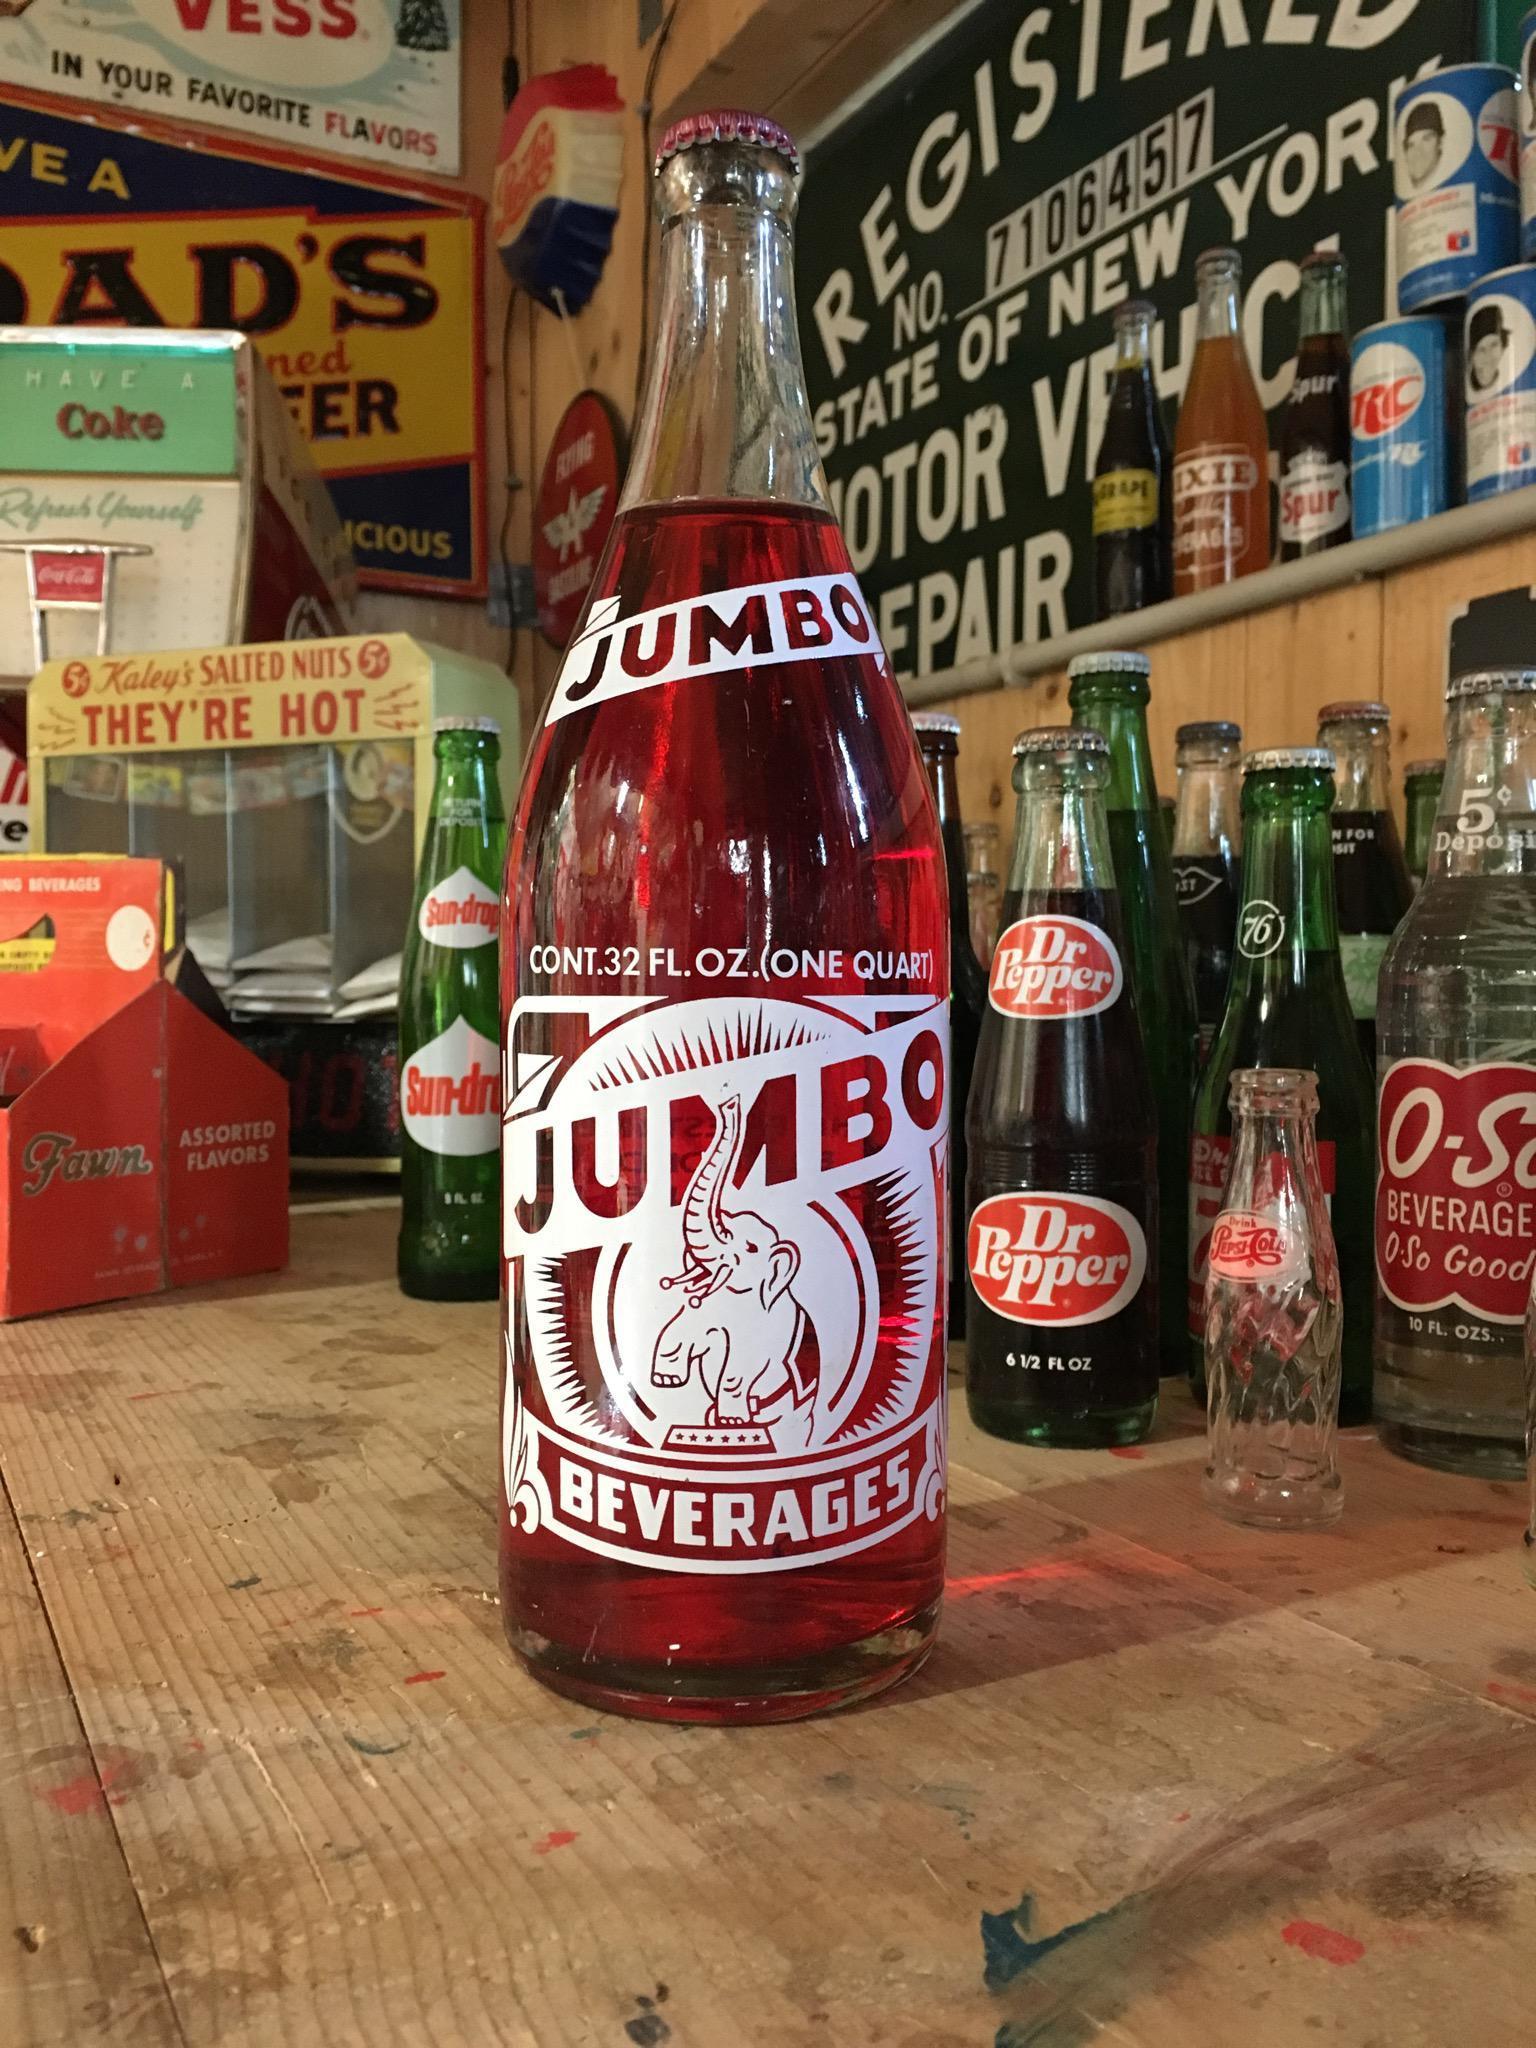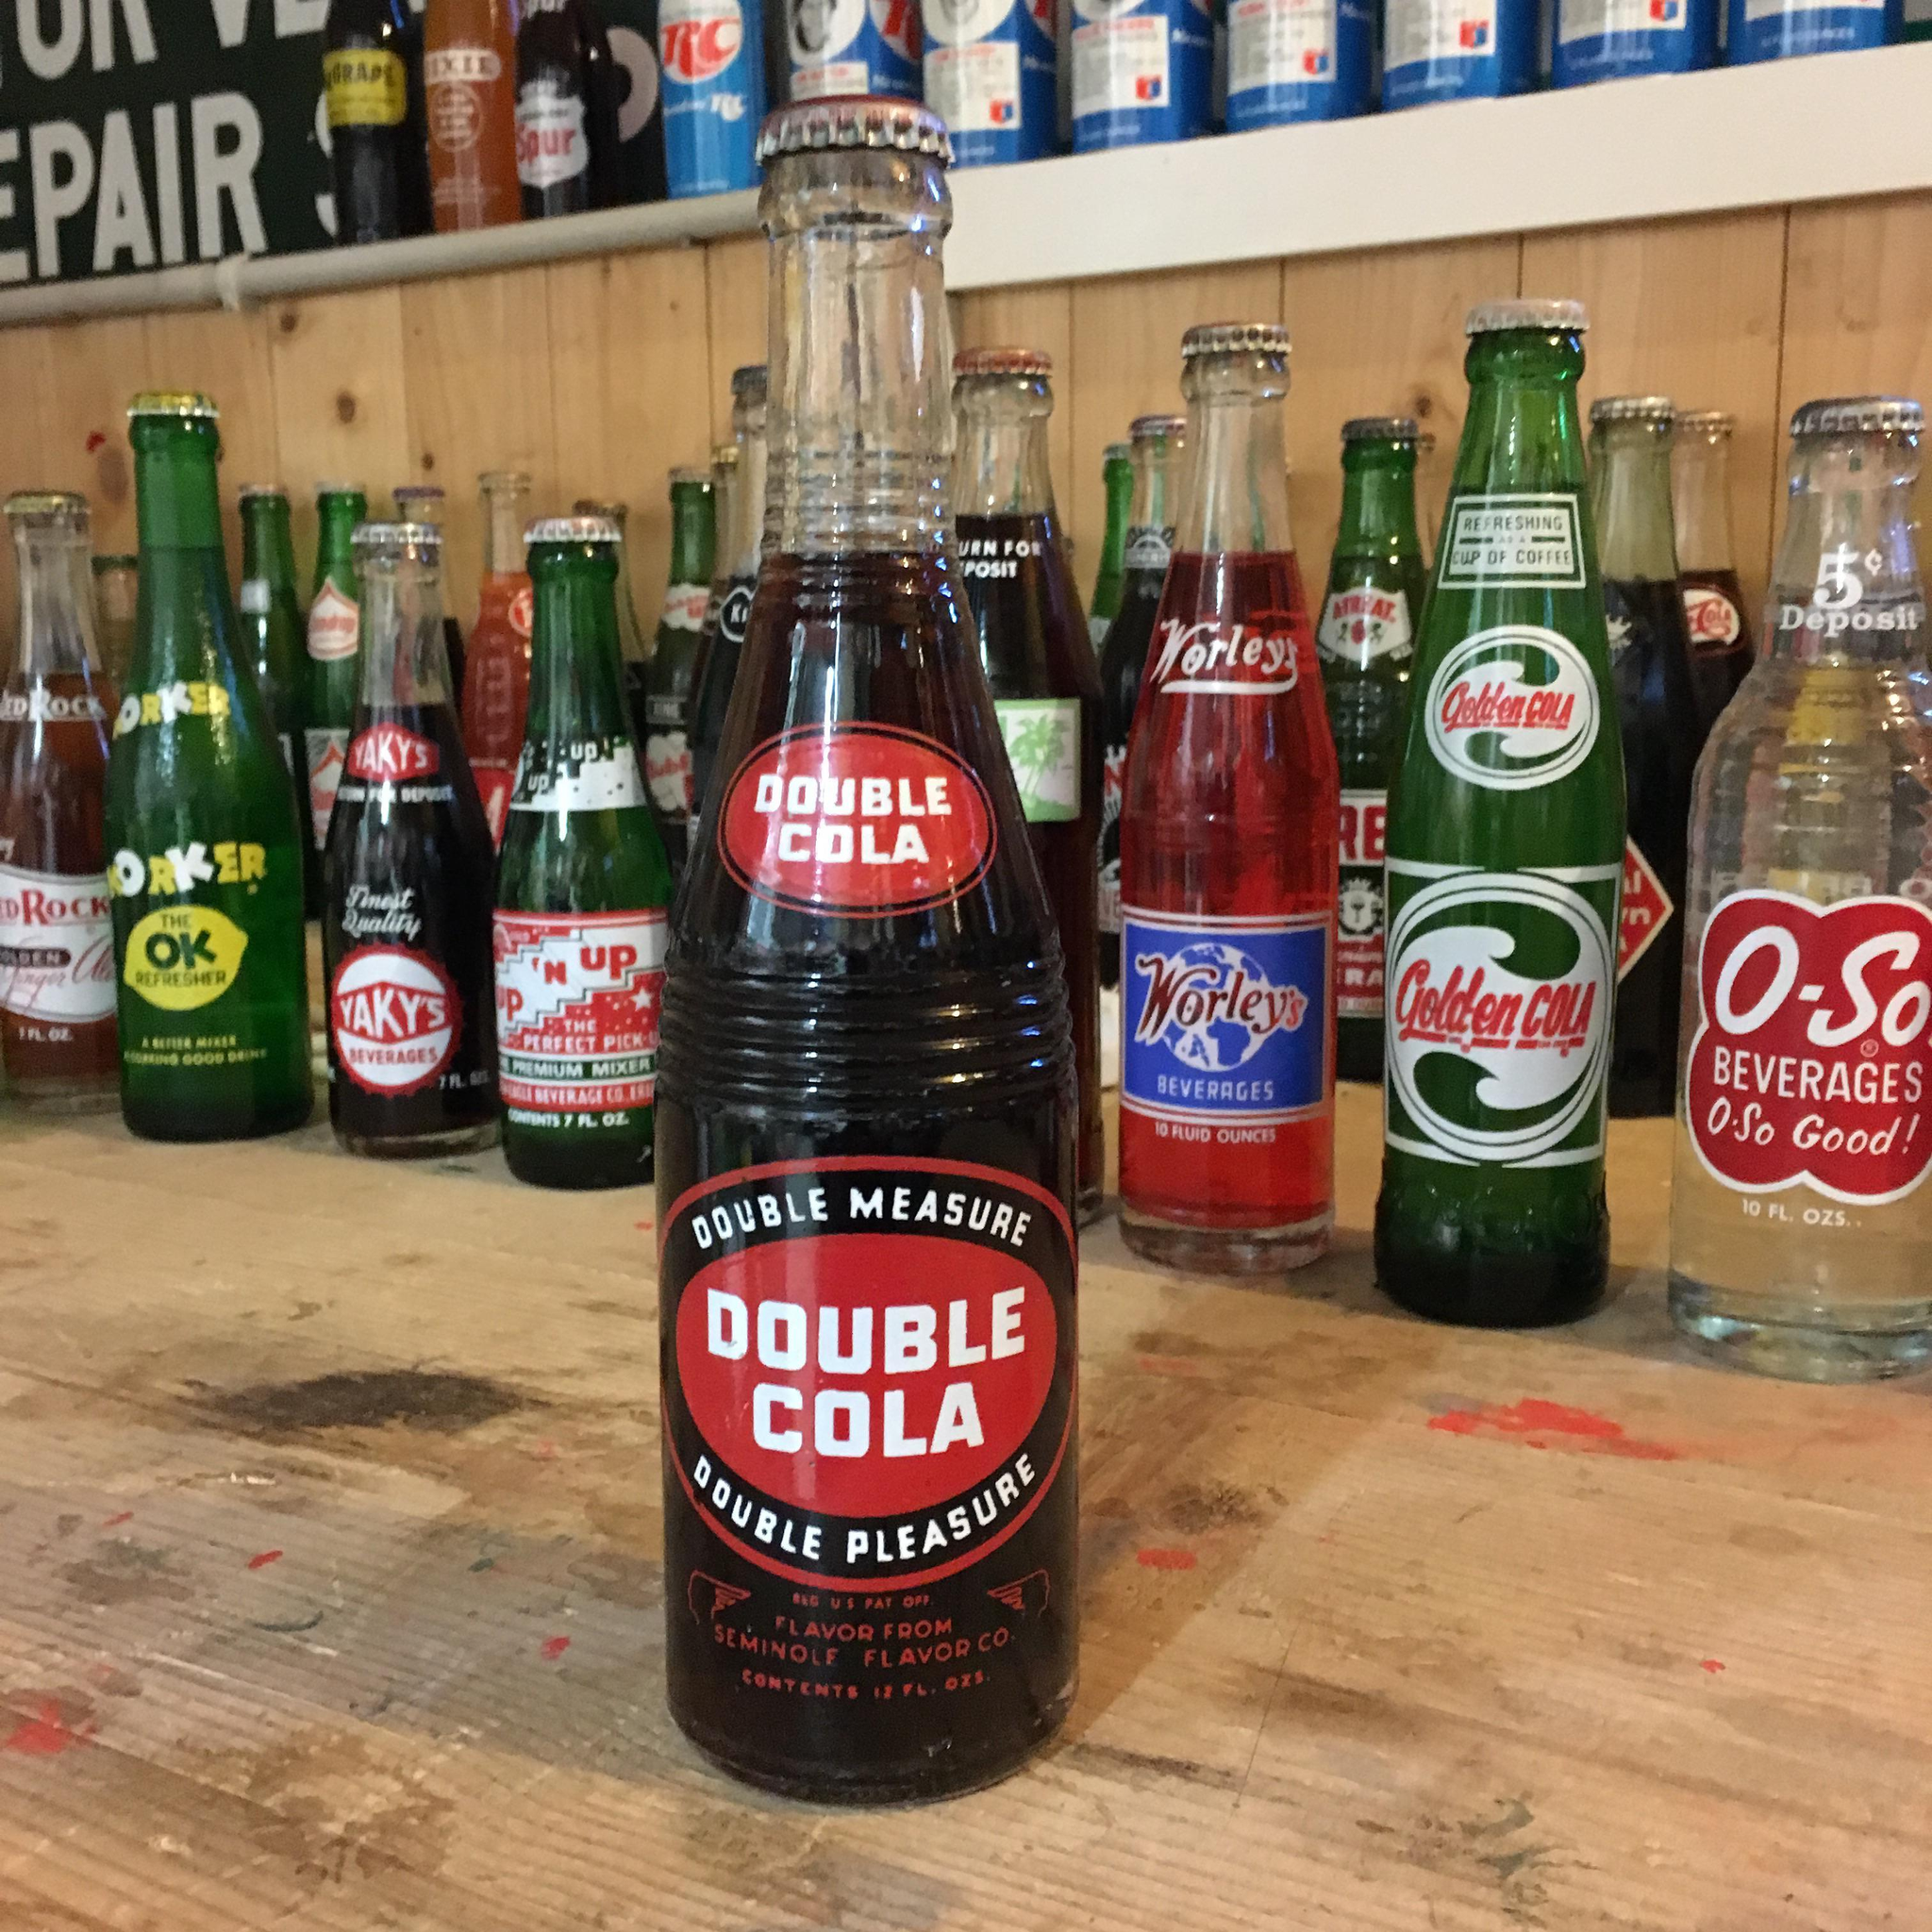The first image is the image on the left, the second image is the image on the right. Examine the images to the left and right. Is the description "The left image features one green bottle of soda standing in front of rows of bottles, and the right image features one clear bottle of brown cola standing in front of rows of bottles." accurate? Answer yes or no. No. The first image is the image on the left, the second image is the image on the right. Examine the images to the left and right. Is the description "Each bottle in front of the group is filled with a black liquid." accurate? Answer yes or no. No. 